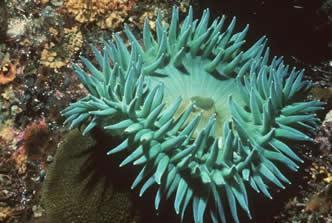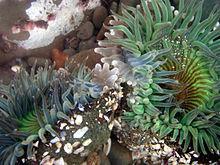The first image is the image on the left, the second image is the image on the right. For the images shown, is this caption "One image shows a flower-like anemone with mint green tendrils and a darker yellowish center with a visible slit in it." true? Answer yes or no. No. 